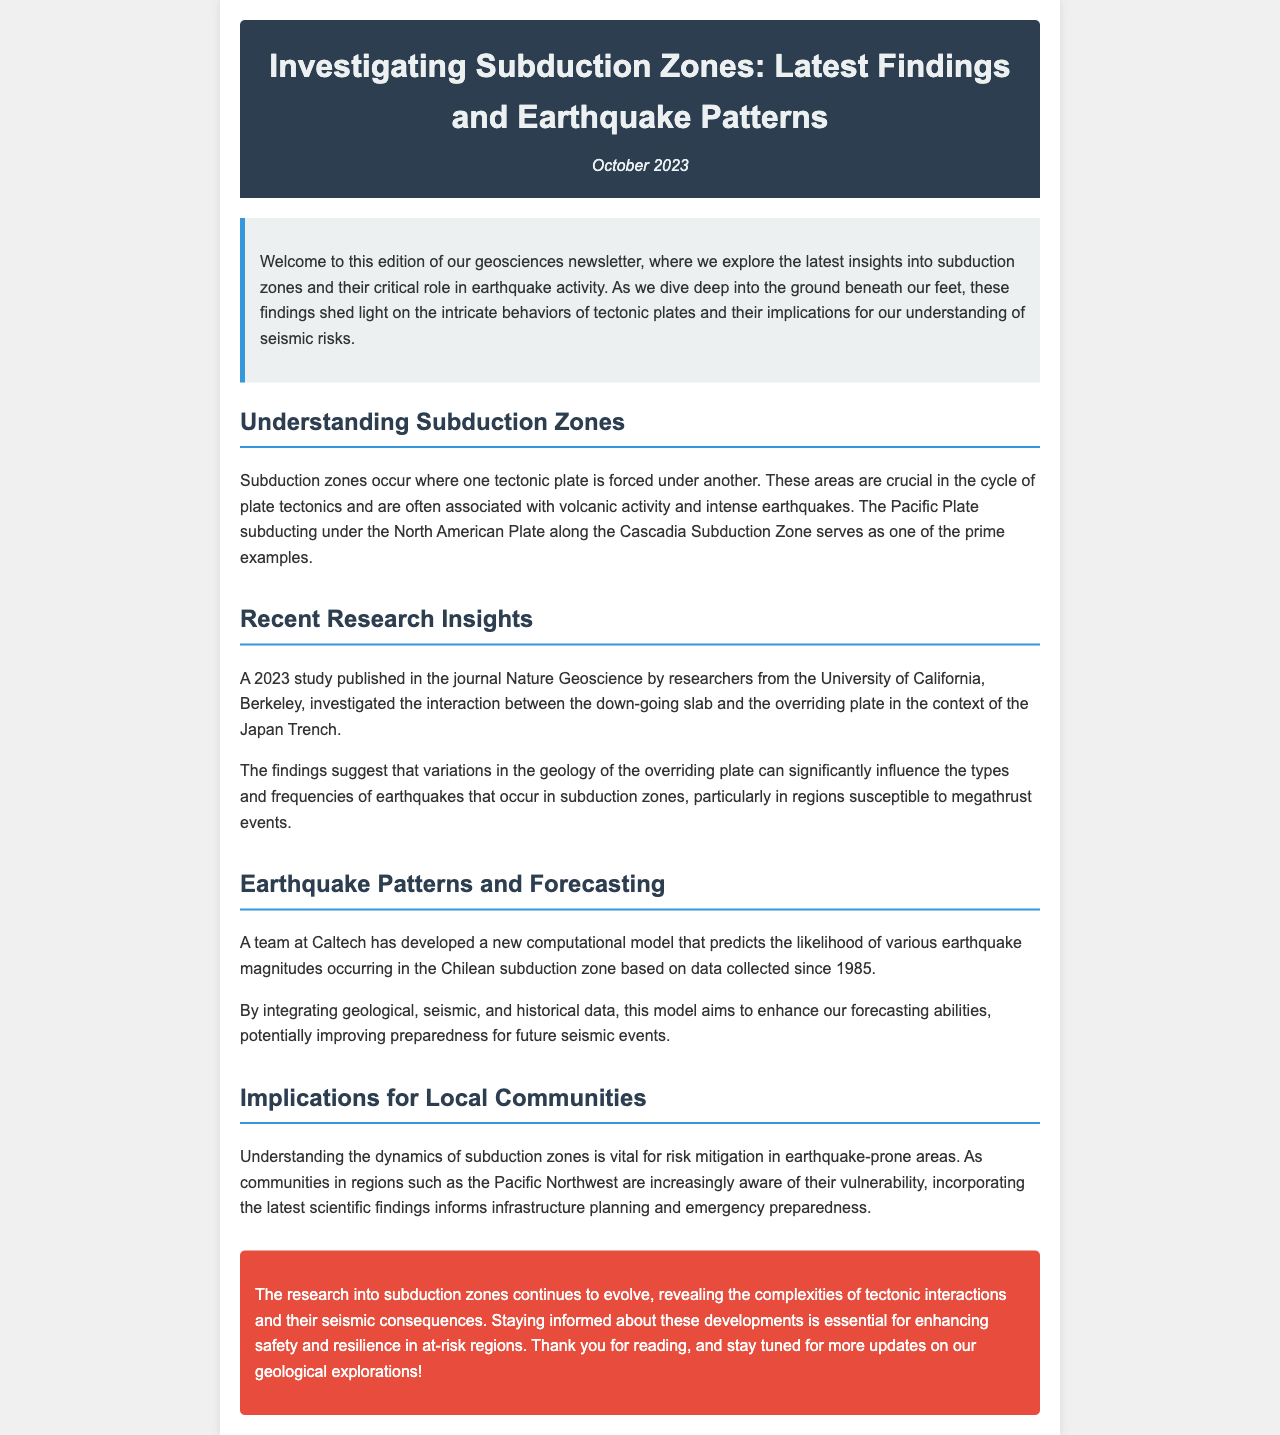what is the title of the newsletter? The title of the newsletter is provided in the header of the document.
Answer: Investigating Subduction Zones: Latest Findings and Earthquake Patterns who conducted the 2023 study published in Nature Geoscience? The document mentions that researchers from the University of California, Berkeley conducted the study.
Answer: University of California, Berkeley what geological feature is associated with the Cascadia Subduction Zone? The document specifies that volcanic activity and intense earthquakes are associated with subduction zones like the Cascadia Subduction Zone.
Answer: volcanic activity and intense earthquakes how many years of data does the computational model from Caltech use? The model developed by Caltech uses data collected since 1985, which is a period of 38 years as of the newsletter date.
Answer: 38 years what is the primary goal of the research mentioned in the newsletter? The research aims to enhance safety and resilience in at-risk regions through a better understanding of subduction zones.
Answer: enhance safety and resilience what do the findings suggest about the overriding plate? The findings indicate that variations in the geology of the overriding plate can influence earthquake types and frequencies.
Answer: influence earthquake types and frequencies which region's communities are increasingly aware of their vulnerability? The document points to communities in the Pacific Northwest regarding their vulnerability to seismic events.
Answer: Pacific Northwest what is the date of publication for this edition? The date of this newsletter edition is mentioned clearly in the header.
Answer: October 2023 